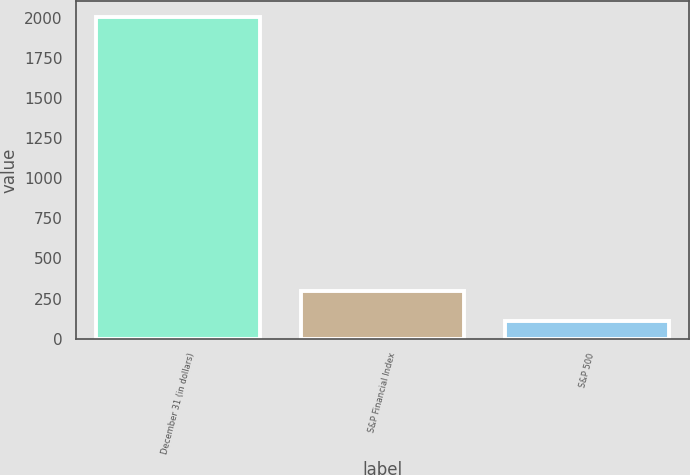Convert chart to OTSL. <chart><loc_0><loc_0><loc_500><loc_500><bar_chart><fcel>December 31 (in dollars)<fcel>S&P Financial Index<fcel>S&P 500<nl><fcel>2004<fcel>300.19<fcel>110.88<nl></chart> 